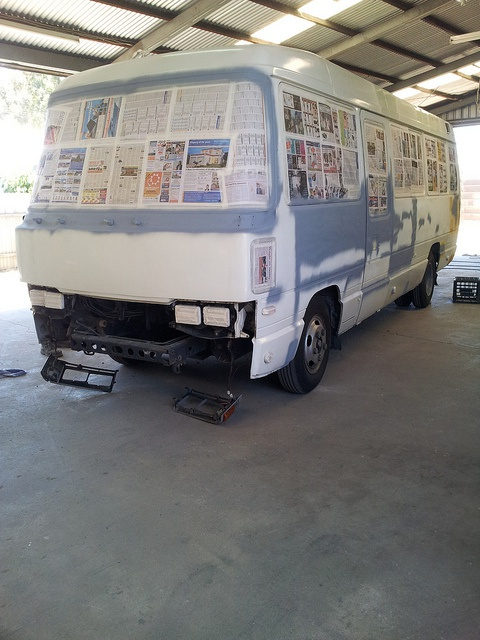Describe the objects in this image and their specific colors. I can see bus in ivory, darkgray, black, gray, and lightgray tones in this image. 